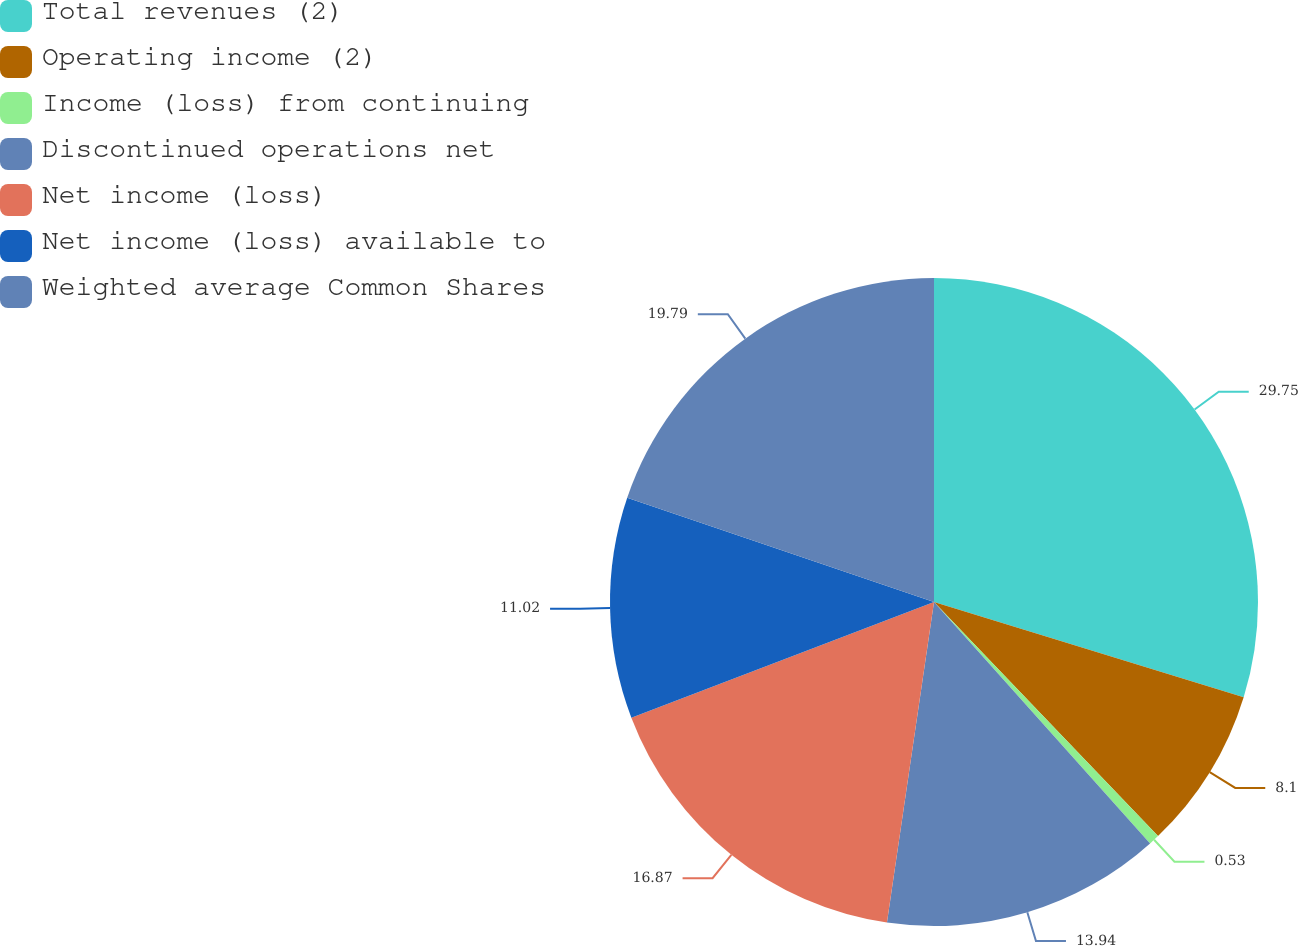Convert chart. <chart><loc_0><loc_0><loc_500><loc_500><pie_chart><fcel>Total revenues (2)<fcel>Operating income (2)<fcel>Income (loss) from continuing<fcel>Discontinued operations net<fcel>Net income (loss)<fcel>Net income (loss) available to<fcel>Weighted average Common Shares<nl><fcel>29.75%<fcel>8.1%<fcel>0.53%<fcel>13.94%<fcel>16.87%<fcel>11.02%<fcel>19.79%<nl></chart> 